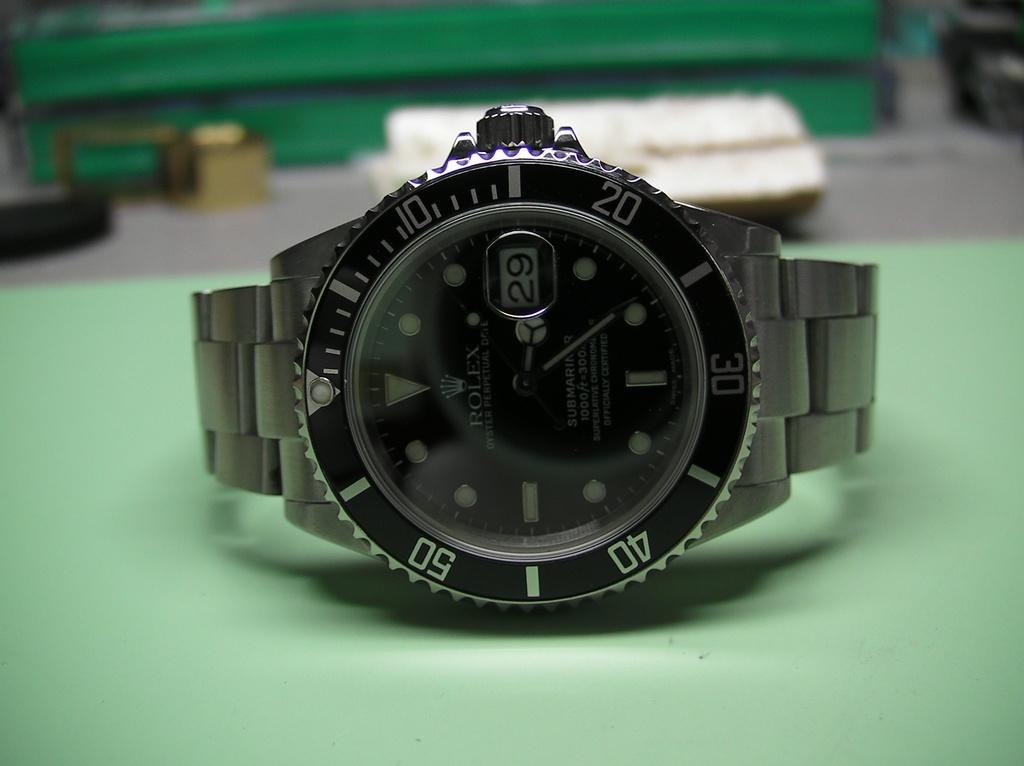<image>
Offer a succinct explanation of the picture presented. A watch lying on a green table has the number 29 in its date window. 